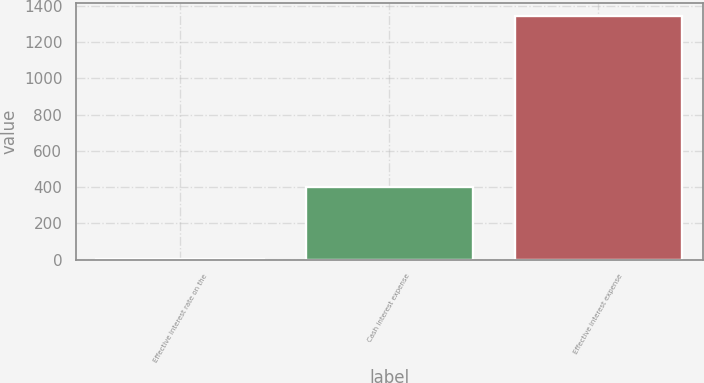Convert chart. <chart><loc_0><loc_0><loc_500><loc_500><bar_chart><fcel>Effective interest rate on the<fcel>Cash interest expense<fcel>Effective interest expense<nl><fcel>6.86<fcel>400<fcel>1345<nl></chart> 